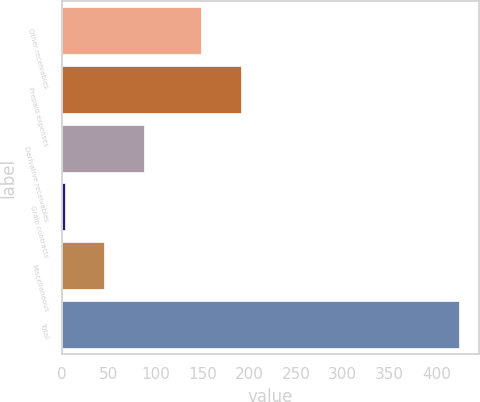<chart> <loc_0><loc_0><loc_500><loc_500><bar_chart><fcel>Other receivables<fcel>Prepaid expenses<fcel>Derivative receivables<fcel>Grain contracts<fcel>Miscellaneous<fcel>Total<nl><fcel>148.8<fcel>190.85<fcel>87.4<fcel>3.3<fcel>45.35<fcel>423.8<nl></chart> 